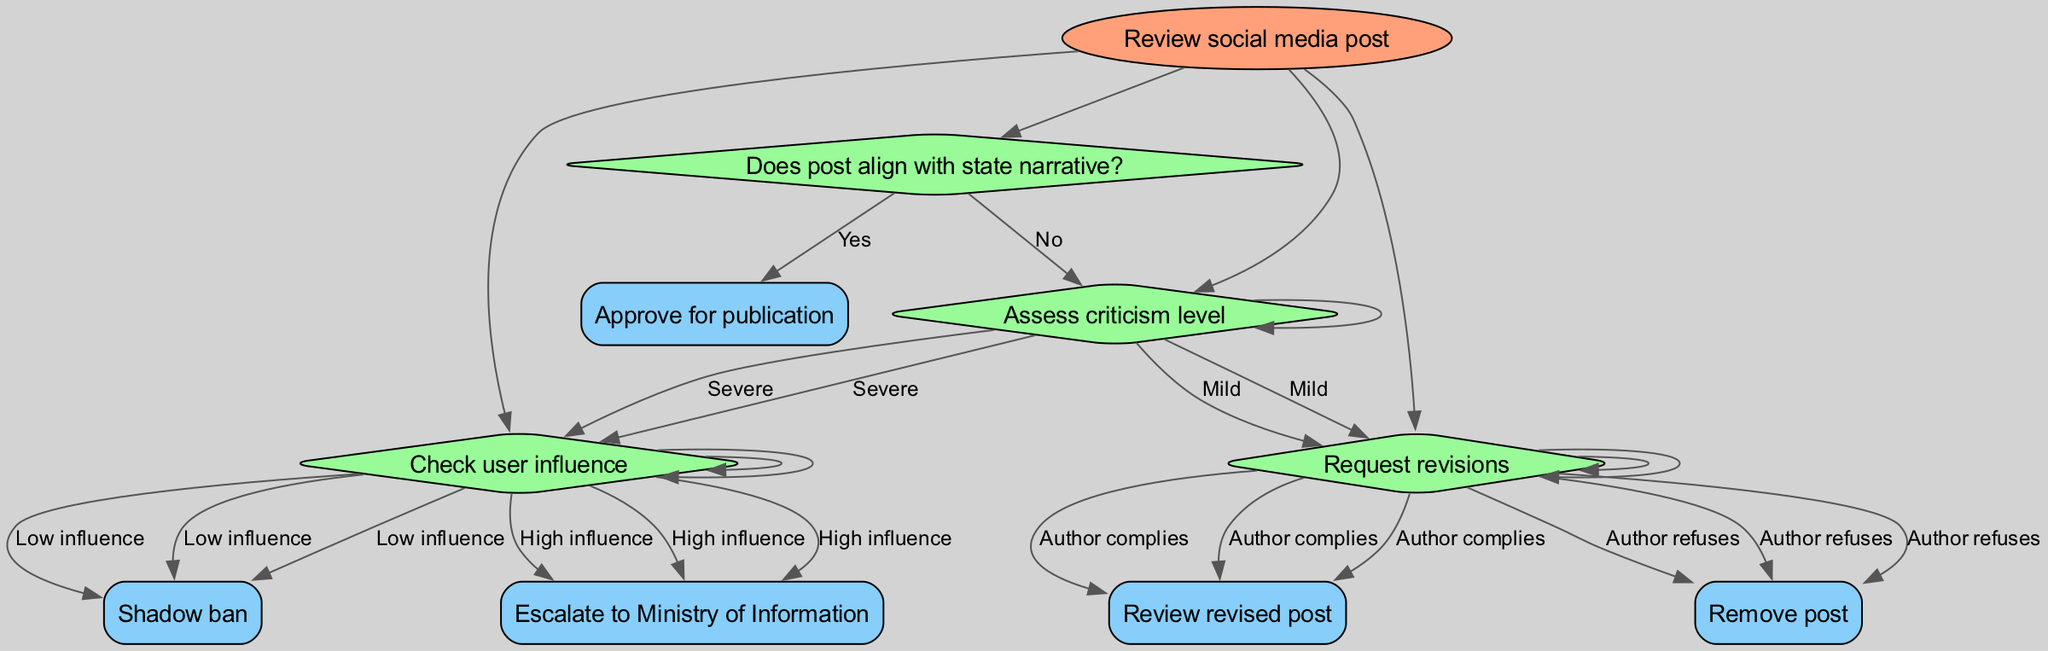What is the root node of the diagram? The root node is the starting point of the decision-making flow, which is "Review social media post".
Answer: Review social media post How many decisions are present in the flowchart? By counting the unique decision nodes, we see there are three primary decisions: "Does post align with state narrative?", "Assess criticism level", and "Check user influence".
Answer: Three What happens if the post aligns with the state narrative? If the post aligns with the state narrative, the next step is to "Approve for publication".
Answer: Approve for publication What is the next step if the criticism level is classified as severe? When the criticism level is severe, we proceed to "Check user influence".
Answer: Check user influence What action is taken if the author refuses to make revisions? If the author refuses to comply with requested revisions, the action taken is to "Remove post".
Answer: Remove post What will happen if the user influence is high? If the user influence is determined to be high, the next step is to "Escalate to Ministry of Information".
Answer: Escalate to Ministry of Information What is the relationship between the "Assess criticism level" node and "Request revisions"? The relationship is that if the post does not align with the state narrative (answering "No"), and if the criticism level is classified as mild, it leads to "Request revisions".
Answer: Leads to Request revisions If the author complies with the revisions, what is the next node? If the author complies with the requested revisions, the following node is "Review revised post".
Answer: Review revised post What kind of influence is categorized as "Low influence"? "Low influence" refers to the status of a user evaluated during the "Check user influence" process, which prompts a "Shadow ban".
Answer: Shadow ban 